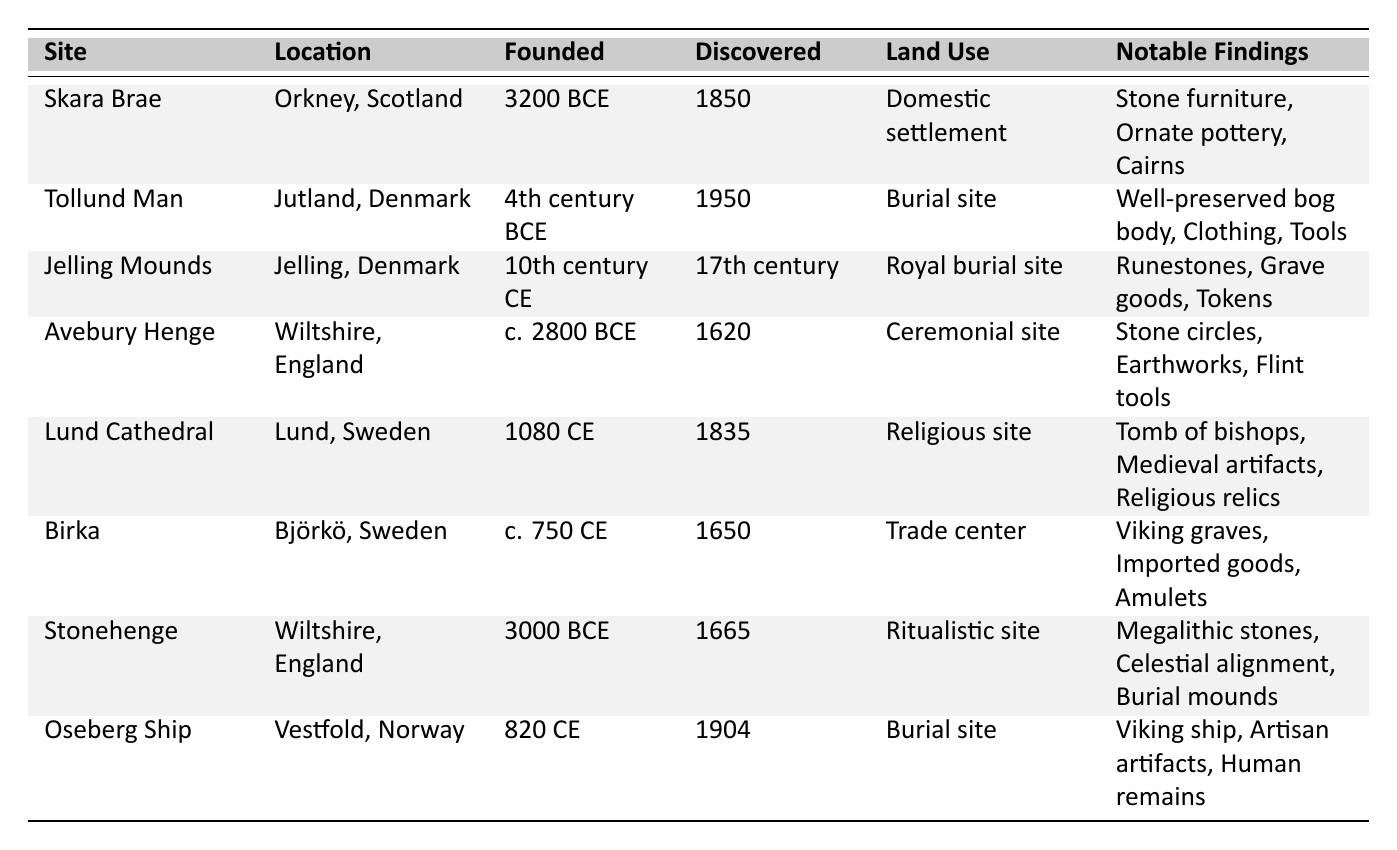What is the location of Skara Brae? Skara Brae is located in Orkney, Scotland, as indicated in the second column of the table.
Answer: Orkney, Scotland When was the Tollund Man discovered? According to the table, the Tollund Man was discovered in 1950, which is stated in the fourth column.
Answer: 1950 Which site has the oldest founding date? By comparing the founding dates in the third column, Skara Brae has the earliest date of 3200 BCE.
Answer: Skara Brae How many burial sites are listed in the table? The burial sites identified in the table are Tollund Man, Jelling Mounds, Oseberg Ship, totaling three sites based on the land use column.
Answer: 3 What notable findings were associated with the Jelling Mounds? The table shows that the notable findings for the Jelling Mounds include runestones, grave goods, and tokens, listed in the last column.
Answer: Runestones, grave goods, tokens Is Avebury Henge used for domestic purposes? By checking the land use column, Avebury Henge is specifically identified as a ceremonial site, not for domestic use.
Answer: No What century was Birka founded? The table indicates that Birka was founded in the 8th century CE, as noted in the third column's entry.
Answer: 8th century CE Which sites were discovered in the 17th century? According to the fourth column, the sites discovered in the 17th century are the Jelling Mounds and Avebury Henge.
Answer: Jelling Mounds, Avebury Henge How many sites were founded in BCE? By reviewing the third column, Skara Brae, Tollund Man, Avebury Henge, and Stonehenge were all founded in BCE, totaling four sites.
Answer: 4 sites What notable findings are shared between Tollund Man and Oseberg Ship? The unique findings for each burial site differ, with Tollund Man noted for a bog body and Oseberg Ship for a Viking ship, showing they do not share notable findings.
Answer: None shared Which site emphasizes its ritualistic land use? The table shows Stonehenge as the site with a ritualistic use, specifically stated in the land use column.
Answer: Stonehenge What is the relationship between the founding dates of Lund Cathedral and Birka? Lund Cathedral was founded in 1080 CE, while Birka was founded around 750 CE, making Lund Cathedral more recent by 330 years.
Answer: Lund Cathedral is more recent Which discovery was made in Norway? Oseberg Ship is listed in the location column as found in Vestfold, Norway, based on the details in the table.
Answer: Oseberg Ship What type of site is Stonehenge categorized as? The table classifies Stonehenge as a ritualistic site, as noted in the land use column.
Answer: Ritualistic site How many notable findings are reported for the site of Lund Cathedral? The table shows that three notable findings related to Lund Cathedral are mentioned: tomb of bishops, medieval artifacts, and religious relics.
Answer: 3 notable findings 